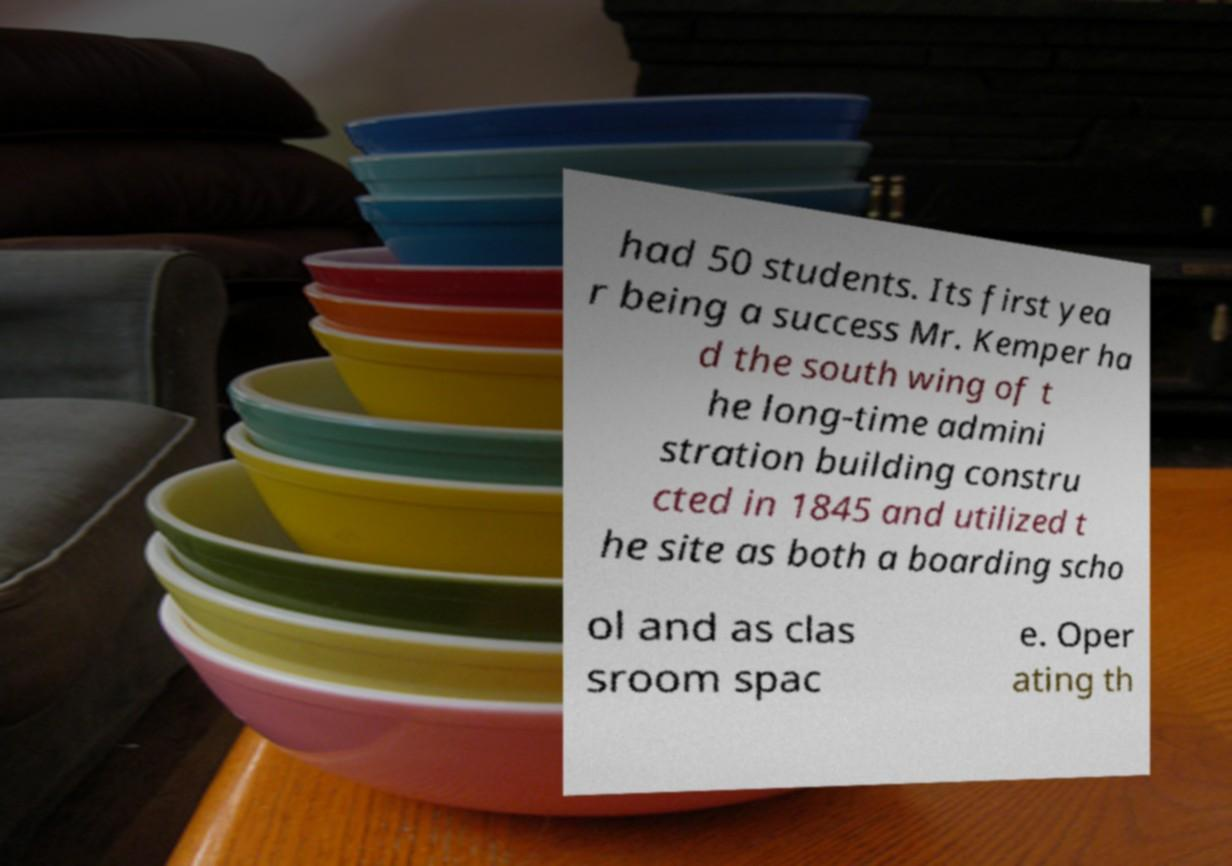I need the written content from this picture converted into text. Can you do that? had 50 students. Its first yea r being a success Mr. Kemper ha d the south wing of t he long-time admini stration building constru cted in 1845 and utilized t he site as both a boarding scho ol and as clas sroom spac e. Oper ating th 